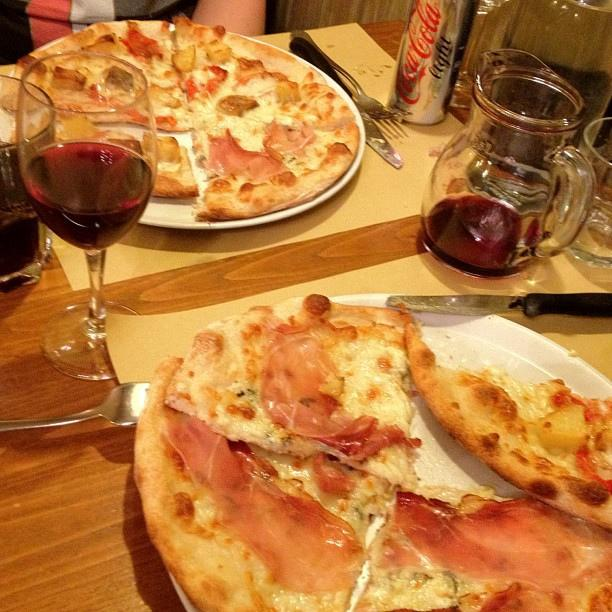Where would you most likely see this type of pizza served with wine? italy 